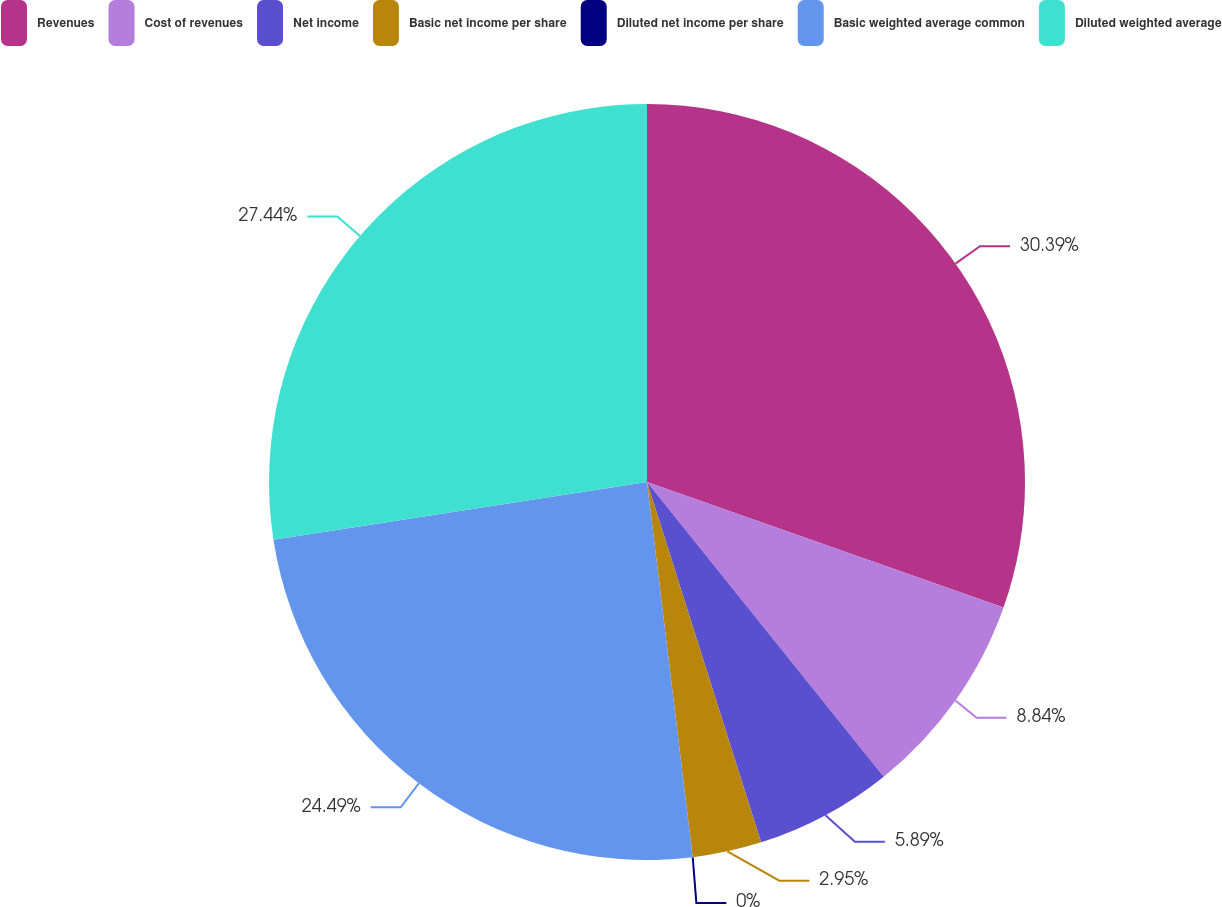Convert chart to OTSL. <chart><loc_0><loc_0><loc_500><loc_500><pie_chart><fcel>Revenues<fcel>Cost of revenues<fcel>Net income<fcel>Basic net income per share<fcel>Diluted net income per share<fcel>Basic weighted average common<fcel>Diluted weighted average<nl><fcel>30.39%<fcel>8.84%<fcel>5.89%<fcel>2.95%<fcel>0.0%<fcel>24.49%<fcel>27.44%<nl></chart> 